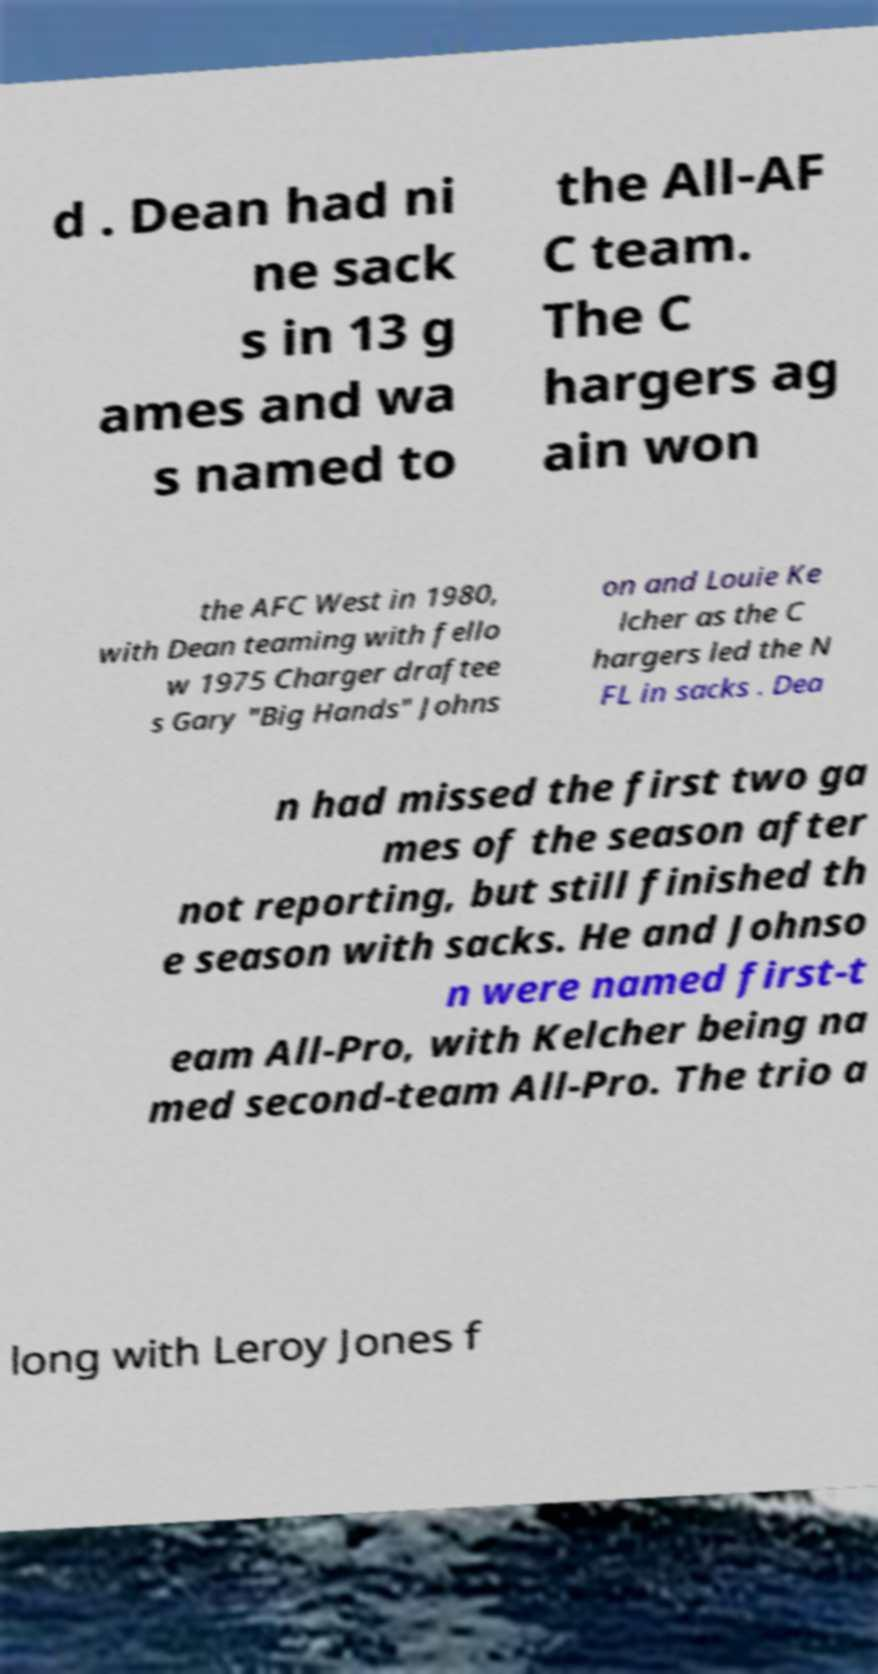What messages or text are displayed in this image? I need them in a readable, typed format. d . Dean had ni ne sack s in 13 g ames and wa s named to the All-AF C team. The C hargers ag ain won the AFC West in 1980, with Dean teaming with fello w 1975 Charger draftee s Gary "Big Hands" Johns on and Louie Ke lcher as the C hargers led the N FL in sacks . Dea n had missed the first two ga mes of the season after not reporting, but still finished th e season with sacks. He and Johnso n were named first-t eam All-Pro, with Kelcher being na med second-team All-Pro. The trio a long with Leroy Jones f 